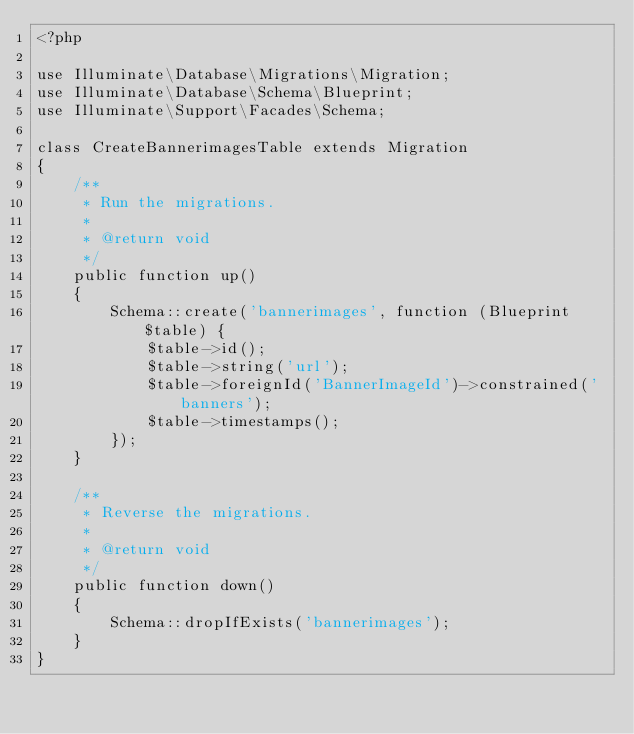Convert code to text. <code><loc_0><loc_0><loc_500><loc_500><_PHP_><?php

use Illuminate\Database\Migrations\Migration;
use Illuminate\Database\Schema\Blueprint;
use Illuminate\Support\Facades\Schema;

class CreateBannerimagesTable extends Migration
{
    /**
     * Run the migrations.
     *
     * @return void
     */
    public function up()
    {
        Schema::create('bannerimages', function (Blueprint $table) {
            $table->id();
            $table->string('url');
            $table->foreignId('BannerImageId')->constrained('banners');
            $table->timestamps();
        });
    }

    /**
     * Reverse the migrations.
     *
     * @return void
     */
    public function down()
    {
        Schema::dropIfExists('bannerimages');
    }
}
</code> 